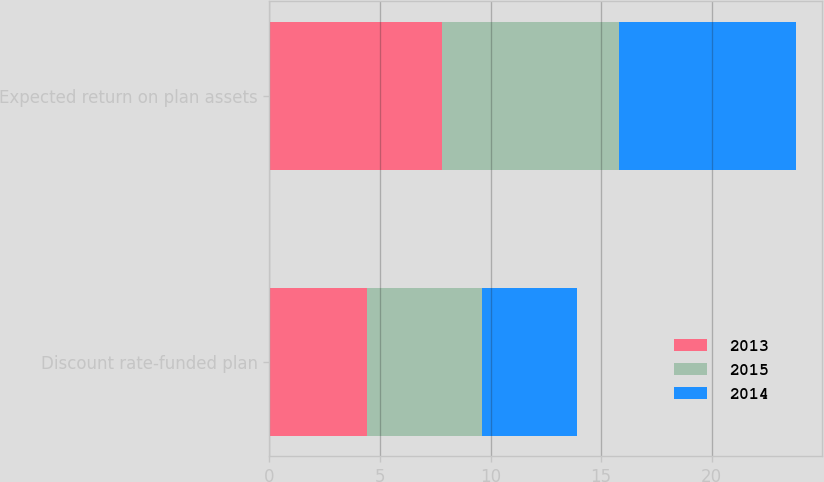Convert chart. <chart><loc_0><loc_0><loc_500><loc_500><stacked_bar_chart><ecel><fcel>Discount rate-funded plan<fcel>Expected return on plan assets<nl><fcel>2013<fcel>4.4<fcel>7.8<nl><fcel>2015<fcel>5.2<fcel>8<nl><fcel>2014<fcel>4.3<fcel>8<nl></chart> 